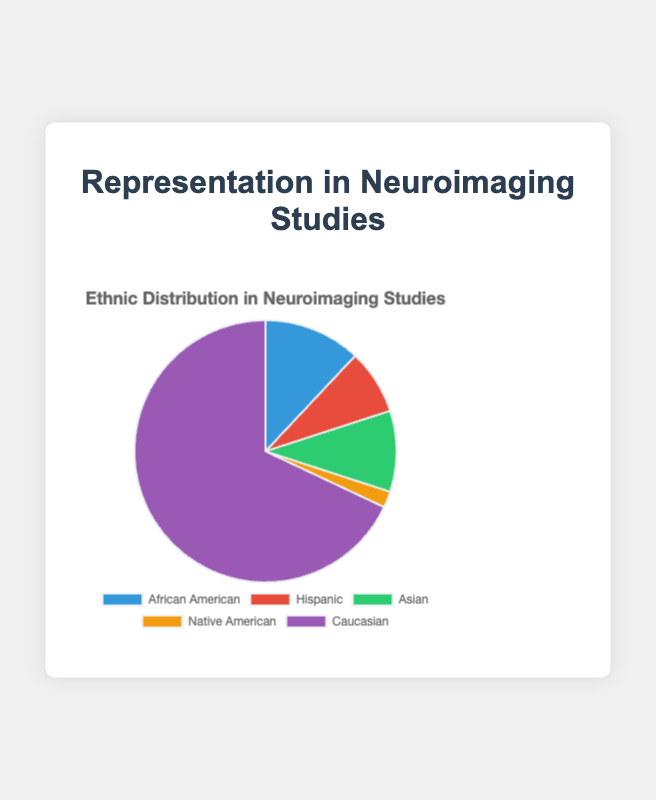What percentage of the representation do Native Americans have? Native Americans have a representation of 2. The pie chart shows the percentage distribution of each group, and we can visually see that "Native American" represents a very small slice of the pie chart.
Answer: 2% Which group has the highest representation in neuroimaging studies? The slice for "Caucasian" is the largest in the pie chart, indicating that this group has the highest representation.
Answer: Caucasian What is the combined percentage of African American and Hispanic representation? African American has a representation of 12% and Hispanic has 8%. Adding these together gives 12 + 8 = 20%.
Answer: 20% Is the representation of Asian groups higher than that of Hispanic groups? The pie chart shows that the percentage representation of Asian is 10% while Hispanic is 8%. 10% is higher than 8%.
Answer: Yes What color represents African Americans in the pie chart? The pie chart uses different colors for each group. The slice labeled "African American" is colored blue.
Answer: Blue What is the sum of the representations of groups other than Caucasian? The representations of African American, Hispanic, Asian, and Native American are 12%, 8%, 10%, and 2% respectively. Summing these, 12 + 8 + 10 + 2 = 32%.
Answer: 32% Is the representation of Native Americans less than half of the Hispanic representation? Native American representation is 2%, and Hispanic representation is 8%. Half of Hispanic representation is 8 / 2 = 4%. Since 2% is less than 4%, the answer is yes.
Answer: Yes How much higher is the Caucasian representation compared to the combined representation of Asian and Hispanic groups? Caucasian representation is 68%. The combined representation of Asian and Hispanic is 10 + 8 = 18%. The difference is 68 - 18 = 50%.
Answer: 50% What is the difference in representation percentages between the highest and the lowest represented groups? Caucasian has the highest representation at 68%, and Native American the lowest at 2%. The difference is 68 - 2 = 66%.
Answer: 66% Which groups have less than 10% representation each? The pie chart shows that Hispanic and Native American groups each have less than 10% representation (8% and 2% respectively).
Answer: Hispanic, Native American 